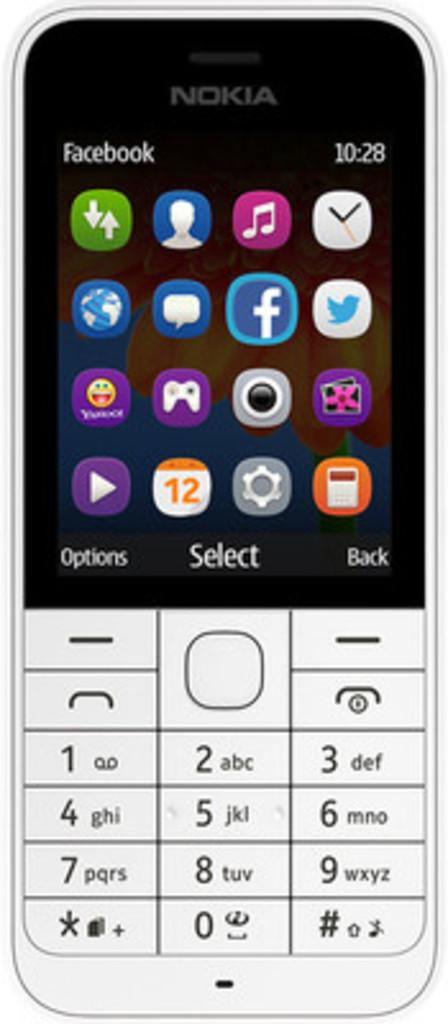<image>
Render a clear and concise summary of the photo. The Nokia phone shows a display of a lot of icons and the time as 10:28. 